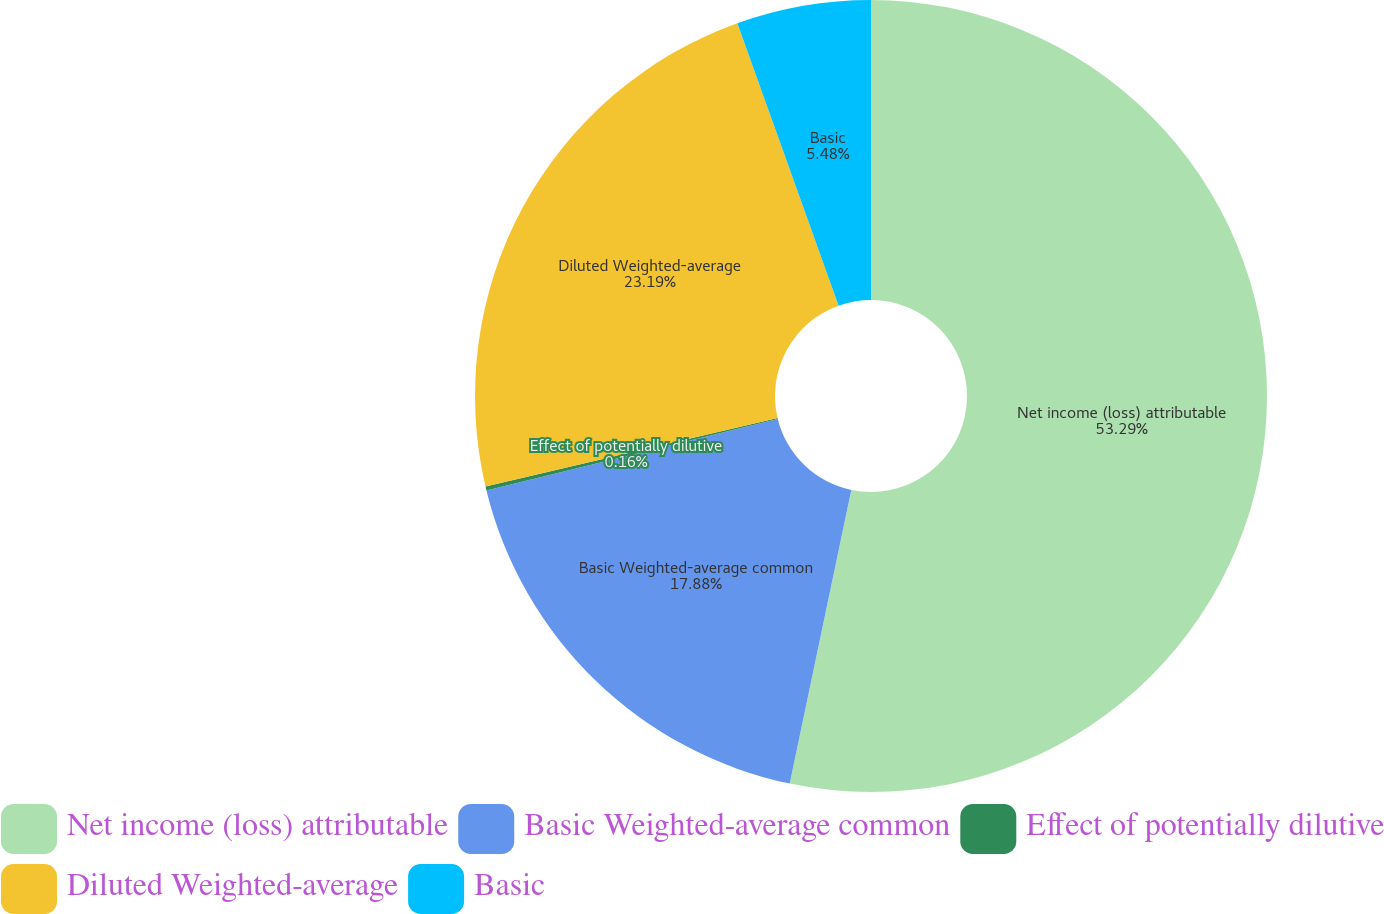Convert chart to OTSL. <chart><loc_0><loc_0><loc_500><loc_500><pie_chart><fcel>Net income (loss) attributable<fcel>Basic Weighted-average common<fcel>Effect of potentially dilutive<fcel>Diluted Weighted-average<fcel>Basic<nl><fcel>53.29%<fcel>17.88%<fcel>0.16%<fcel>23.19%<fcel>5.48%<nl></chart> 